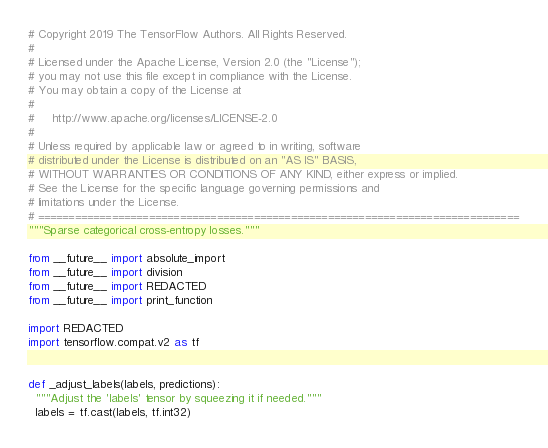Convert code to text. <code><loc_0><loc_0><loc_500><loc_500><_Python_># Copyright 2019 The TensorFlow Authors. All Rights Reserved.
#
# Licensed under the Apache License, Version 2.0 (the "License");
# you may not use this file except in compliance with the License.
# You may obtain a copy of the License at
#
#     http://www.apache.org/licenses/LICENSE-2.0
#
# Unless required by applicable law or agreed to in writing, software
# distributed under the License is distributed on an "AS IS" BASIS,
# WITHOUT WARRANTIES OR CONDITIONS OF ANY KIND, either express or implied.
# See the License for the specific language governing permissions and
# limitations under the License.
# ==============================================================================
"""Sparse categorical cross-entropy losses."""

from __future__ import absolute_import
from __future__ import division
from __future__ import REDACTED
from __future__ import print_function

import REDACTED
import tensorflow.compat.v2 as tf


def _adjust_labels(labels, predictions):
  """Adjust the 'labels' tensor by squeezing it if needed."""
  labels = tf.cast(labels, tf.int32)</code> 